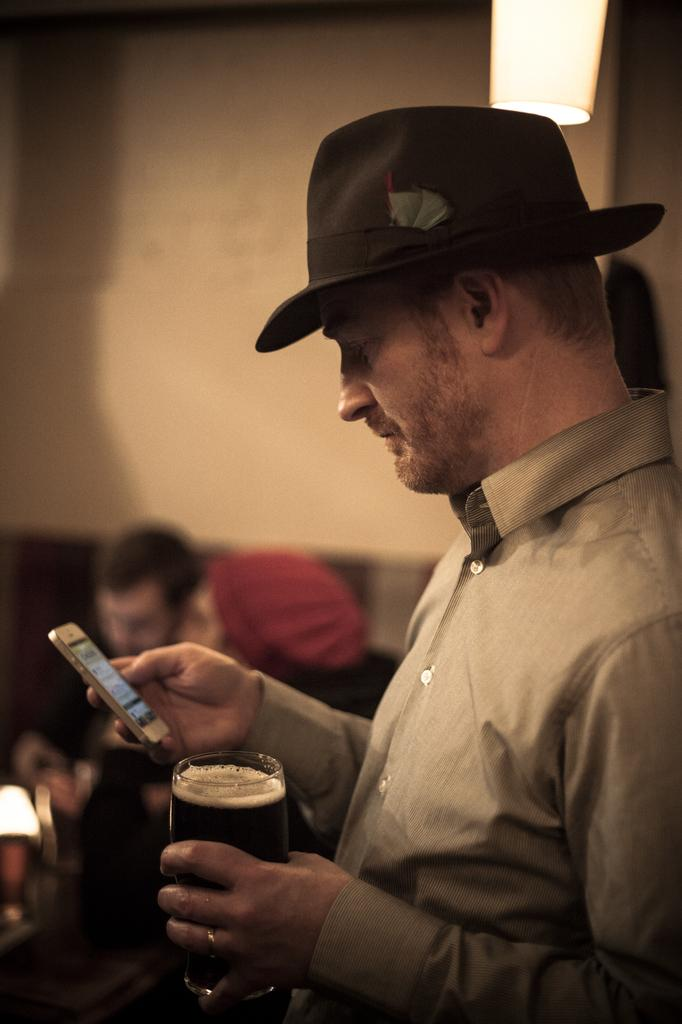What is the main subject of the image? The main subject of the image is a man. What is the man holding in the image? The man is holding a glass and a mobile. What type of wilderness can be seen in the background of the image? There is no wilderness visible in the image; it only features a man holding a glass and a mobile. 